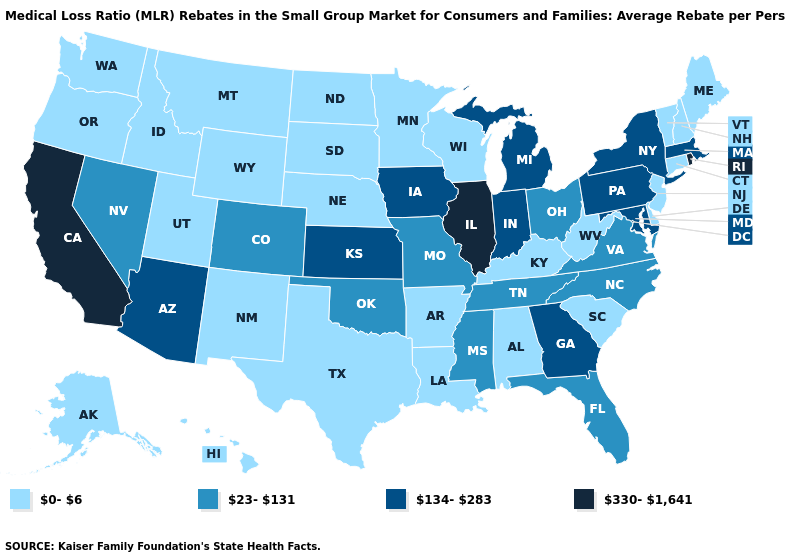Among the states that border California , which have the lowest value?
Be succinct. Oregon. Name the states that have a value in the range 0-6?
Short answer required. Alabama, Alaska, Arkansas, Connecticut, Delaware, Hawaii, Idaho, Kentucky, Louisiana, Maine, Minnesota, Montana, Nebraska, New Hampshire, New Jersey, New Mexico, North Dakota, Oregon, South Carolina, South Dakota, Texas, Utah, Vermont, Washington, West Virginia, Wisconsin, Wyoming. Does Hawaii have a higher value than Massachusetts?
Be succinct. No. Name the states that have a value in the range 23-131?
Be succinct. Colorado, Florida, Mississippi, Missouri, Nevada, North Carolina, Ohio, Oklahoma, Tennessee, Virginia. Does Alaska have the highest value in the West?
Quick response, please. No. How many symbols are there in the legend?
Short answer required. 4. Name the states that have a value in the range 134-283?
Quick response, please. Arizona, Georgia, Indiana, Iowa, Kansas, Maryland, Massachusetts, Michigan, New York, Pennsylvania. What is the value of Massachusetts?
Write a very short answer. 134-283. Name the states that have a value in the range 134-283?
Concise answer only. Arizona, Georgia, Indiana, Iowa, Kansas, Maryland, Massachusetts, Michigan, New York, Pennsylvania. What is the lowest value in the West?
Give a very brief answer. 0-6. Name the states that have a value in the range 23-131?
Concise answer only. Colorado, Florida, Mississippi, Missouri, Nevada, North Carolina, Ohio, Oklahoma, Tennessee, Virginia. What is the value of Iowa?
Write a very short answer. 134-283. Does Alaska have the highest value in the West?
Be succinct. No. Name the states that have a value in the range 330-1,641?
Keep it brief. California, Illinois, Rhode Island. 